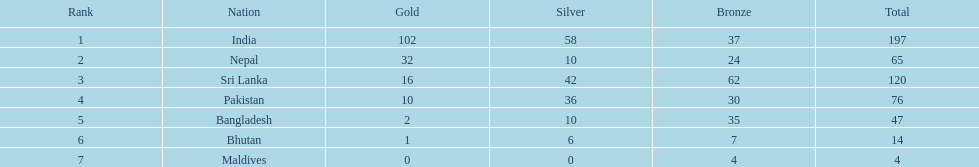Name the first country on the table? India. 